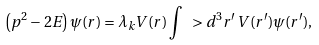<formula> <loc_0><loc_0><loc_500><loc_500>\left ( { p } ^ { 2 } - 2 E \right ) \psi ( { r } ) = \lambda _ { k } V ( r ) \int \ > d ^ { 3 } r ^ { \prime } \, V ( r ^ { \prime } ) \psi ( { r } ^ { \prime } ) ,</formula> 